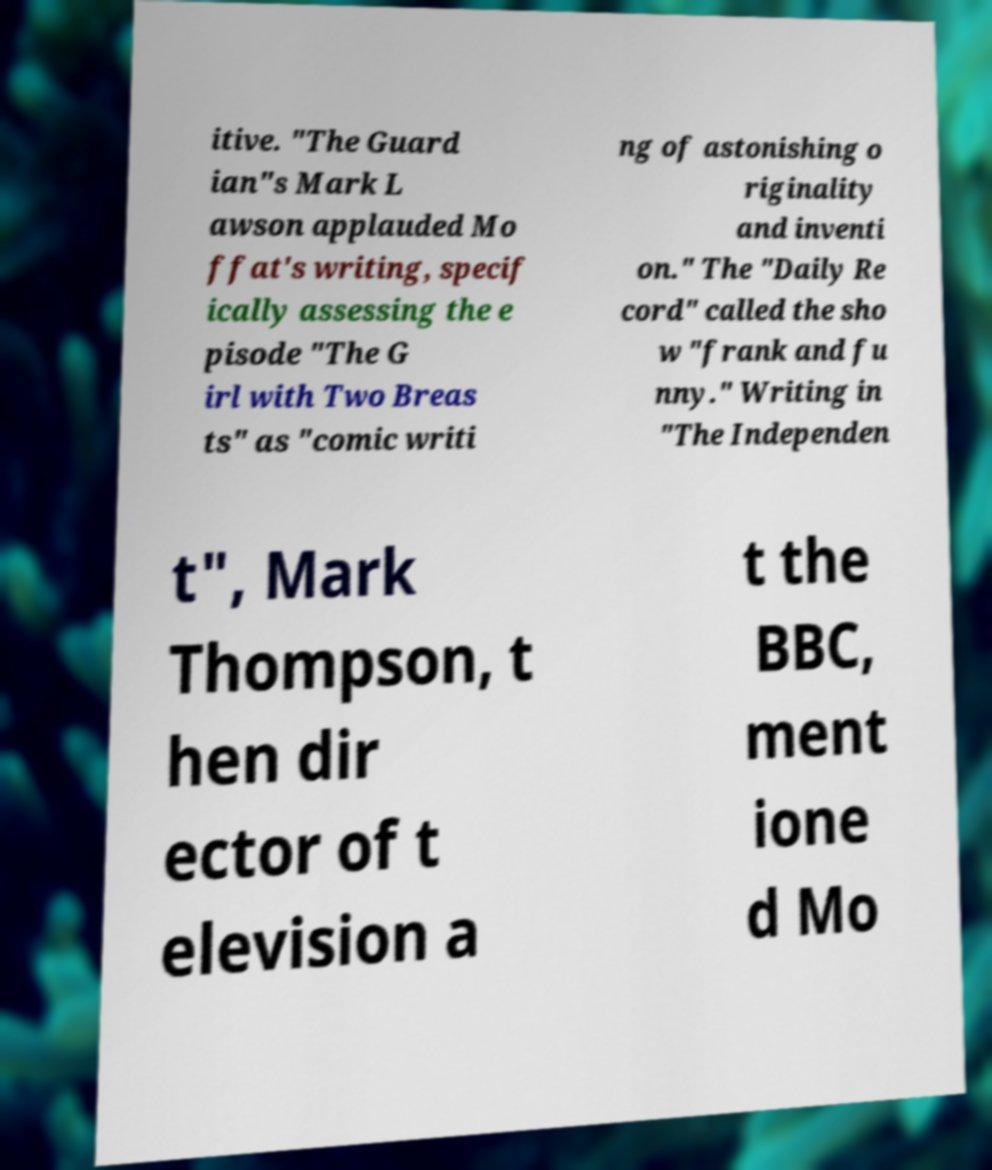Can you accurately transcribe the text from the provided image for me? itive. "The Guard ian"s Mark L awson applauded Mo ffat's writing, specif ically assessing the e pisode "The G irl with Two Breas ts" as "comic writi ng of astonishing o riginality and inventi on." The "Daily Re cord" called the sho w "frank and fu nny." Writing in "The Independen t", Mark Thompson, t hen dir ector of t elevision a t the BBC, ment ione d Mo 